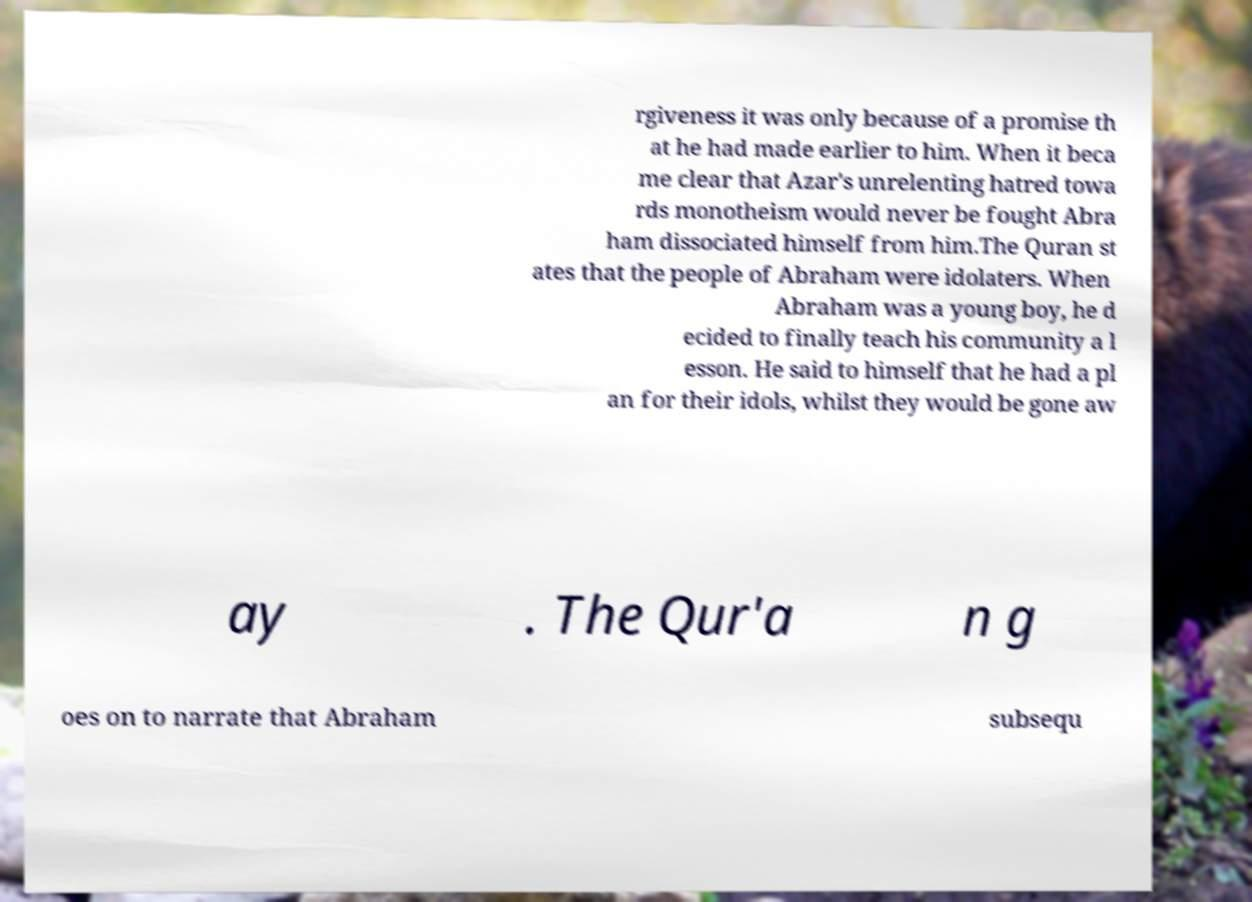Please identify and transcribe the text found in this image. rgiveness it was only because of a promise th at he had made earlier to him. When it beca me clear that Azar's unrelenting hatred towa rds monotheism would never be fought Abra ham dissociated himself from him.The Quran st ates that the people of Abraham were idolaters. When Abraham was a young boy, he d ecided to finally teach his community a l esson. He said to himself that he had a pl an for their idols, whilst they would be gone aw ay . The Qur'a n g oes on to narrate that Abraham subsequ 